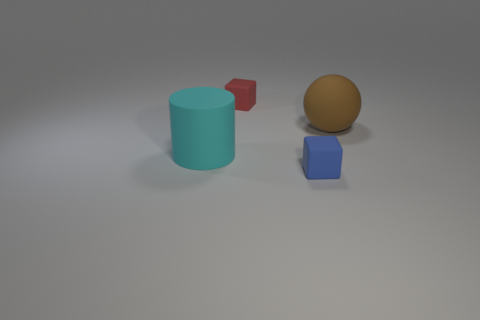Add 1 large rubber balls. How many objects exist? 5 Subtract all gray cylinders. Subtract all gray cubes. How many cylinders are left? 1 Subtract all balls. How many objects are left? 3 Add 2 tiny blue rubber objects. How many tiny blue rubber objects exist? 3 Subtract 0 gray blocks. How many objects are left? 4 Subtract all red matte balls. Subtract all balls. How many objects are left? 3 Add 2 rubber cylinders. How many rubber cylinders are left? 3 